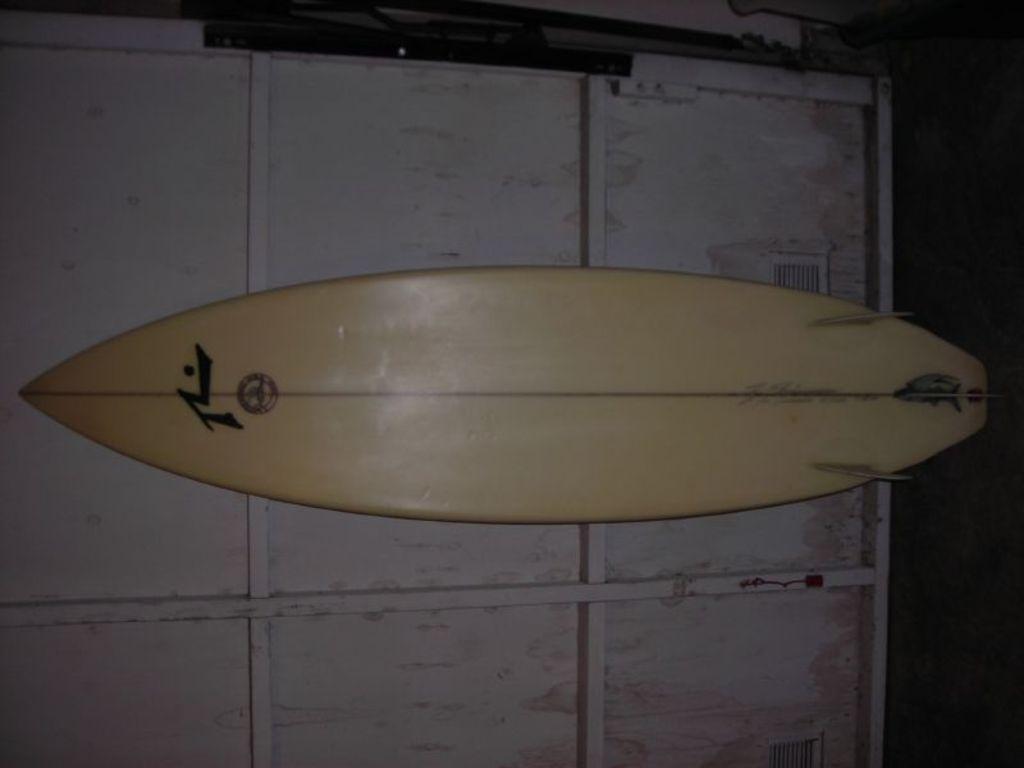Could you give a brief overview of what you see in this image? In the image we can see there is a surfing board which is kept on the wall. 